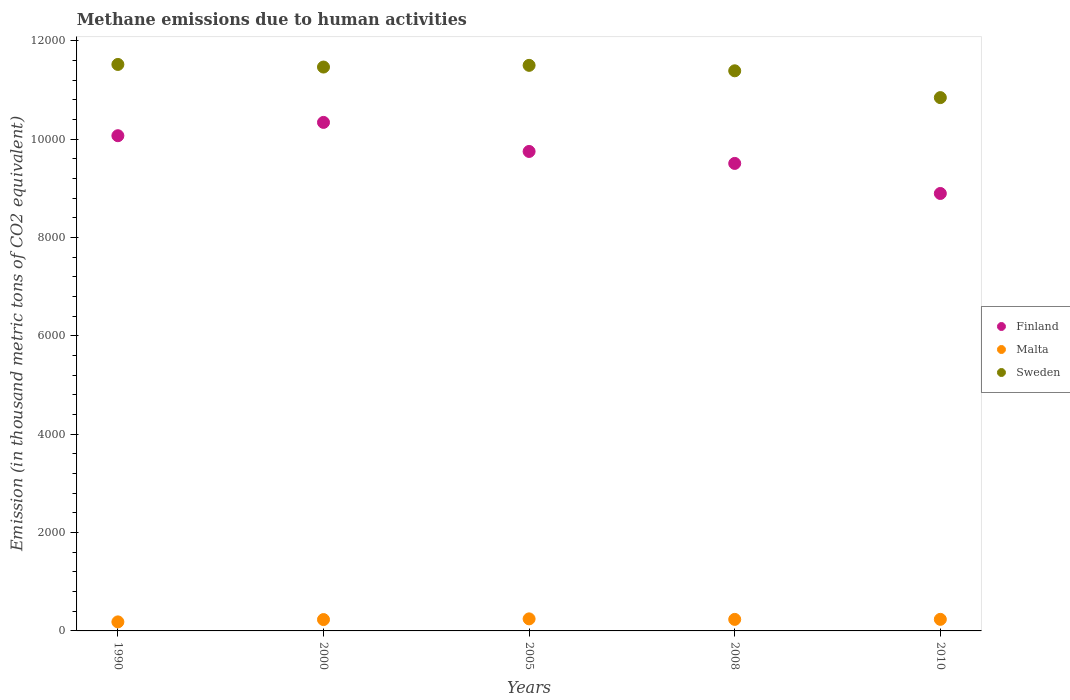How many different coloured dotlines are there?
Give a very brief answer. 3. What is the amount of methane emitted in Sweden in 2000?
Keep it short and to the point. 1.15e+04. Across all years, what is the maximum amount of methane emitted in Malta?
Your answer should be very brief. 245.1. Across all years, what is the minimum amount of methane emitted in Finland?
Your answer should be compact. 8895.5. In which year was the amount of methane emitted in Sweden minimum?
Offer a very short reply. 2010. What is the total amount of methane emitted in Finland in the graph?
Provide a short and direct response. 4.86e+04. What is the difference between the amount of methane emitted in Malta in 2008 and that in 2010?
Your response must be concise. -0.9. What is the difference between the amount of methane emitted in Sweden in 2000 and the amount of methane emitted in Finland in 2010?
Offer a terse response. 2570.8. What is the average amount of methane emitted in Finland per year?
Your answer should be very brief. 9712.64. In the year 2010, what is the difference between the amount of methane emitted in Sweden and amount of methane emitted in Malta?
Give a very brief answer. 1.06e+04. In how many years, is the amount of methane emitted in Malta greater than 9200 thousand metric tons?
Offer a very short reply. 0. What is the ratio of the amount of methane emitted in Sweden in 2008 to that in 2010?
Make the answer very short. 1.05. Is the difference between the amount of methane emitted in Sweden in 1990 and 2008 greater than the difference between the amount of methane emitted in Malta in 1990 and 2008?
Make the answer very short. Yes. What is the difference between the highest and the second highest amount of methane emitted in Finland?
Give a very brief answer. 270.6. What is the difference between the highest and the lowest amount of methane emitted in Sweden?
Give a very brief answer. 674.5. In how many years, is the amount of methane emitted in Finland greater than the average amount of methane emitted in Finland taken over all years?
Offer a terse response. 3. Is the sum of the amount of methane emitted in Malta in 1990 and 2000 greater than the maximum amount of methane emitted in Sweden across all years?
Offer a very short reply. No. Is it the case that in every year, the sum of the amount of methane emitted in Malta and amount of methane emitted in Sweden  is greater than the amount of methane emitted in Finland?
Your answer should be very brief. Yes. Does the amount of methane emitted in Malta monotonically increase over the years?
Provide a succinct answer. No. Is the amount of methane emitted in Finland strictly less than the amount of methane emitted in Malta over the years?
Your answer should be compact. No. How many dotlines are there?
Your answer should be very brief. 3. How many years are there in the graph?
Your answer should be very brief. 5. Are the values on the major ticks of Y-axis written in scientific E-notation?
Your answer should be compact. No. Where does the legend appear in the graph?
Your answer should be very brief. Center right. How many legend labels are there?
Give a very brief answer. 3. How are the legend labels stacked?
Keep it short and to the point. Vertical. What is the title of the graph?
Offer a terse response. Methane emissions due to human activities. Does "Liberia" appear as one of the legend labels in the graph?
Give a very brief answer. No. What is the label or title of the Y-axis?
Give a very brief answer. Emission (in thousand metric tons of CO2 equivalent). What is the Emission (in thousand metric tons of CO2 equivalent) in Finland in 1990?
Your answer should be compact. 1.01e+04. What is the Emission (in thousand metric tons of CO2 equivalent) in Malta in 1990?
Make the answer very short. 183.7. What is the Emission (in thousand metric tons of CO2 equivalent) of Sweden in 1990?
Offer a terse response. 1.15e+04. What is the Emission (in thousand metric tons of CO2 equivalent) in Finland in 2000?
Your answer should be compact. 1.03e+04. What is the Emission (in thousand metric tons of CO2 equivalent) in Malta in 2000?
Offer a very short reply. 230.8. What is the Emission (in thousand metric tons of CO2 equivalent) in Sweden in 2000?
Offer a very short reply. 1.15e+04. What is the Emission (in thousand metric tons of CO2 equivalent) in Finland in 2005?
Your answer should be very brief. 9750. What is the Emission (in thousand metric tons of CO2 equivalent) of Malta in 2005?
Keep it short and to the point. 245.1. What is the Emission (in thousand metric tons of CO2 equivalent) of Sweden in 2005?
Make the answer very short. 1.15e+04. What is the Emission (in thousand metric tons of CO2 equivalent) in Finland in 2008?
Ensure brevity in your answer.  9506.7. What is the Emission (in thousand metric tons of CO2 equivalent) of Malta in 2008?
Give a very brief answer. 234.5. What is the Emission (in thousand metric tons of CO2 equivalent) in Sweden in 2008?
Your answer should be very brief. 1.14e+04. What is the Emission (in thousand metric tons of CO2 equivalent) of Finland in 2010?
Ensure brevity in your answer.  8895.5. What is the Emission (in thousand metric tons of CO2 equivalent) in Malta in 2010?
Provide a succinct answer. 235.4. What is the Emission (in thousand metric tons of CO2 equivalent) of Sweden in 2010?
Your response must be concise. 1.08e+04. Across all years, what is the maximum Emission (in thousand metric tons of CO2 equivalent) of Finland?
Provide a succinct answer. 1.03e+04. Across all years, what is the maximum Emission (in thousand metric tons of CO2 equivalent) in Malta?
Your answer should be very brief. 245.1. Across all years, what is the maximum Emission (in thousand metric tons of CO2 equivalent) in Sweden?
Keep it short and to the point. 1.15e+04. Across all years, what is the minimum Emission (in thousand metric tons of CO2 equivalent) in Finland?
Provide a short and direct response. 8895.5. Across all years, what is the minimum Emission (in thousand metric tons of CO2 equivalent) in Malta?
Offer a terse response. 183.7. Across all years, what is the minimum Emission (in thousand metric tons of CO2 equivalent) in Sweden?
Your response must be concise. 1.08e+04. What is the total Emission (in thousand metric tons of CO2 equivalent) of Finland in the graph?
Provide a short and direct response. 4.86e+04. What is the total Emission (in thousand metric tons of CO2 equivalent) of Malta in the graph?
Your response must be concise. 1129.5. What is the total Emission (in thousand metric tons of CO2 equivalent) in Sweden in the graph?
Give a very brief answer. 5.67e+04. What is the difference between the Emission (in thousand metric tons of CO2 equivalent) in Finland in 1990 and that in 2000?
Your answer should be very brief. -270.6. What is the difference between the Emission (in thousand metric tons of CO2 equivalent) in Malta in 1990 and that in 2000?
Provide a succinct answer. -47.1. What is the difference between the Emission (in thousand metric tons of CO2 equivalent) in Finland in 1990 and that in 2005?
Provide a succinct answer. 320.2. What is the difference between the Emission (in thousand metric tons of CO2 equivalent) of Malta in 1990 and that in 2005?
Ensure brevity in your answer.  -61.4. What is the difference between the Emission (in thousand metric tons of CO2 equivalent) of Sweden in 1990 and that in 2005?
Offer a very short reply. 18.4. What is the difference between the Emission (in thousand metric tons of CO2 equivalent) of Finland in 1990 and that in 2008?
Ensure brevity in your answer.  563.5. What is the difference between the Emission (in thousand metric tons of CO2 equivalent) of Malta in 1990 and that in 2008?
Ensure brevity in your answer.  -50.8. What is the difference between the Emission (in thousand metric tons of CO2 equivalent) of Sweden in 1990 and that in 2008?
Give a very brief answer. 129.2. What is the difference between the Emission (in thousand metric tons of CO2 equivalent) in Finland in 1990 and that in 2010?
Offer a very short reply. 1174.7. What is the difference between the Emission (in thousand metric tons of CO2 equivalent) in Malta in 1990 and that in 2010?
Provide a succinct answer. -51.7. What is the difference between the Emission (in thousand metric tons of CO2 equivalent) in Sweden in 1990 and that in 2010?
Your response must be concise. 674.5. What is the difference between the Emission (in thousand metric tons of CO2 equivalent) in Finland in 2000 and that in 2005?
Keep it short and to the point. 590.8. What is the difference between the Emission (in thousand metric tons of CO2 equivalent) of Malta in 2000 and that in 2005?
Give a very brief answer. -14.3. What is the difference between the Emission (in thousand metric tons of CO2 equivalent) of Sweden in 2000 and that in 2005?
Ensure brevity in your answer.  -34.6. What is the difference between the Emission (in thousand metric tons of CO2 equivalent) in Finland in 2000 and that in 2008?
Your response must be concise. 834.1. What is the difference between the Emission (in thousand metric tons of CO2 equivalent) of Sweden in 2000 and that in 2008?
Offer a terse response. 76.2. What is the difference between the Emission (in thousand metric tons of CO2 equivalent) in Finland in 2000 and that in 2010?
Offer a terse response. 1445.3. What is the difference between the Emission (in thousand metric tons of CO2 equivalent) in Malta in 2000 and that in 2010?
Your answer should be very brief. -4.6. What is the difference between the Emission (in thousand metric tons of CO2 equivalent) of Sweden in 2000 and that in 2010?
Provide a short and direct response. 621.5. What is the difference between the Emission (in thousand metric tons of CO2 equivalent) in Finland in 2005 and that in 2008?
Your answer should be compact. 243.3. What is the difference between the Emission (in thousand metric tons of CO2 equivalent) of Sweden in 2005 and that in 2008?
Ensure brevity in your answer.  110.8. What is the difference between the Emission (in thousand metric tons of CO2 equivalent) in Finland in 2005 and that in 2010?
Your response must be concise. 854.5. What is the difference between the Emission (in thousand metric tons of CO2 equivalent) in Malta in 2005 and that in 2010?
Your answer should be compact. 9.7. What is the difference between the Emission (in thousand metric tons of CO2 equivalent) in Sweden in 2005 and that in 2010?
Offer a very short reply. 656.1. What is the difference between the Emission (in thousand metric tons of CO2 equivalent) of Finland in 2008 and that in 2010?
Ensure brevity in your answer.  611.2. What is the difference between the Emission (in thousand metric tons of CO2 equivalent) in Malta in 2008 and that in 2010?
Offer a terse response. -0.9. What is the difference between the Emission (in thousand metric tons of CO2 equivalent) in Sweden in 2008 and that in 2010?
Provide a short and direct response. 545.3. What is the difference between the Emission (in thousand metric tons of CO2 equivalent) in Finland in 1990 and the Emission (in thousand metric tons of CO2 equivalent) in Malta in 2000?
Provide a succinct answer. 9839.4. What is the difference between the Emission (in thousand metric tons of CO2 equivalent) of Finland in 1990 and the Emission (in thousand metric tons of CO2 equivalent) of Sweden in 2000?
Offer a very short reply. -1396.1. What is the difference between the Emission (in thousand metric tons of CO2 equivalent) of Malta in 1990 and the Emission (in thousand metric tons of CO2 equivalent) of Sweden in 2000?
Keep it short and to the point. -1.13e+04. What is the difference between the Emission (in thousand metric tons of CO2 equivalent) of Finland in 1990 and the Emission (in thousand metric tons of CO2 equivalent) of Malta in 2005?
Offer a terse response. 9825.1. What is the difference between the Emission (in thousand metric tons of CO2 equivalent) in Finland in 1990 and the Emission (in thousand metric tons of CO2 equivalent) in Sweden in 2005?
Your answer should be compact. -1430.7. What is the difference between the Emission (in thousand metric tons of CO2 equivalent) of Malta in 1990 and the Emission (in thousand metric tons of CO2 equivalent) of Sweden in 2005?
Provide a short and direct response. -1.13e+04. What is the difference between the Emission (in thousand metric tons of CO2 equivalent) in Finland in 1990 and the Emission (in thousand metric tons of CO2 equivalent) in Malta in 2008?
Your response must be concise. 9835.7. What is the difference between the Emission (in thousand metric tons of CO2 equivalent) of Finland in 1990 and the Emission (in thousand metric tons of CO2 equivalent) of Sweden in 2008?
Provide a succinct answer. -1319.9. What is the difference between the Emission (in thousand metric tons of CO2 equivalent) in Malta in 1990 and the Emission (in thousand metric tons of CO2 equivalent) in Sweden in 2008?
Your answer should be very brief. -1.12e+04. What is the difference between the Emission (in thousand metric tons of CO2 equivalent) in Finland in 1990 and the Emission (in thousand metric tons of CO2 equivalent) in Malta in 2010?
Ensure brevity in your answer.  9834.8. What is the difference between the Emission (in thousand metric tons of CO2 equivalent) in Finland in 1990 and the Emission (in thousand metric tons of CO2 equivalent) in Sweden in 2010?
Your response must be concise. -774.6. What is the difference between the Emission (in thousand metric tons of CO2 equivalent) of Malta in 1990 and the Emission (in thousand metric tons of CO2 equivalent) of Sweden in 2010?
Offer a terse response. -1.07e+04. What is the difference between the Emission (in thousand metric tons of CO2 equivalent) of Finland in 2000 and the Emission (in thousand metric tons of CO2 equivalent) of Malta in 2005?
Your answer should be very brief. 1.01e+04. What is the difference between the Emission (in thousand metric tons of CO2 equivalent) in Finland in 2000 and the Emission (in thousand metric tons of CO2 equivalent) in Sweden in 2005?
Offer a terse response. -1160.1. What is the difference between the Emission (in thousand metric tons of CO2 equivalent) in Malta in 2000 and the Emission (in thousand metric tons of CO2 equivalent) in Sweden in 2005?
Your answer should be compact. -1.13e+04. What is the difference between the Emission (in thousand metric tons of CO2 equivalent) of Finland in 2000 and the Emission (in thousand metric tons of CO2 equivalent) of Malta in 2008?
Provide a succinct answer. 1.01e+04. What is the difference between the Emission (in thousand metric tons of CO2 equivalent) in Finland in 2000 and the Emission (in thousand metric tons of CO2 equivalent) in Sweden in 2008?
Your response must be concise. -1049.3. What is the difference between the Emission (in thousand metric tons of CO2 equivalent) in Malta in 2000 and the Emission (in thousand metric tons of CO2 equivalent) in Sweden in 2008?
Your response must be concise. -1.12e+04. What is the difference between the Emission (in thousand metric tons of CO2 equivalent) in Finland in 2000 and the Emission (in thousand metric tons of CO2 equivalent) in Malta in 2010?
Provide a short and direct response. 1.01e+04. What is the difference between the Emission (in thousand metric tons of CO2 equivalent) of Finland in 2000 and the Emission (in thousand metric tons of CO2 equivalent) of Sweden in 2010?
Your response must be concise. -504. What is the difference between the Emission (in thousand metric tons of CO2 equivalent) of Malta in 2000 and the Emission (in thousand metric tons of CO2 equivalent) of Sweden in 2010?
Ensure brevity in your answer.  -1.06e+04. What is the difference between the Emission (in thousand metric tons of CO2 equivalent) in Finland in 2005 and the Emission (in thousand metric tons of CO2 equivalent) in Malta in 2008?
Make the answer very short. 9515.5. What is the difference between the Emission (in thousand metric tons of CO2 equivalent) in Finland in 2005 and the Emission (in thousand metric tons of CO2 equivalent) in Sweden in 2008?
Your answer should be very brief. -1640.1. What is the difference between the Emission (in thousand metric tons of CO2 equivalent) in Malta in 2005 and the Emission (in thousand metric tons of CO2 equivalent) in Sweden in 2008?
Offer a terse response. -1.11e+04. What is the difference between the Emission (in thousand metric tons of CO2 equivalent) of Finland in 2005 and the Emission (in thousand metric tons of CO2 equivalent) of Malta in 2010?
Ensure brevity in your answer.  9514.6. What is the difference between the Emission (in thousand metric tons of CO2 equivalent) of Finland in 2005 and the Emission (in thousand metric tons of CO2 equivalent) of Sweden in 2010?
Ensure brevity in your answer.  -1094.8. What is the difference between the Emission (in thousand metric tons of CO2 equivalent) of Malta in 2005 and the Emission (in thousand metric tons of CO2 equivalent) of Sweden in 2010?
Ensure brevity in your answer.  -1.06e+04. What is the difference between the Emission (in thousand metric tons of CO2 equivalent) of Finland in 2008 and the Emission (in thousand metric tons of CO2 equivalent) of Malta in 2010?
Make the answer very short. 9271.3. What is the difference between the Emission (in thousand metric tons of CO2 equivalent) of Finland in 2008 and the Emission (in thousand metric tons of CO2 equivalent) of Sweden in 2010?
Offer a terse response. -1338.1. What is the difference between the Emission (in thousand metric tons of CO2 equivalent) in Malta in 2008 and the Emission (in thousand metric tons of CO2 equivalent) in Sweden in 2010?
Offer a terse response. -1.06e+04. What is the average Emission (in thousand metric tons of CO2 equivalent) in Finland per year?
Make the answer very short. 9712.64. What is the average Emission (in thousand metric tons of CO2 equivalent) in Malta per year?
Offer a terse response. 225.9. What is the average Emission (in thousand metric tons of CO2 equivalent) in Sweden per year?
Offer a terse response. 1.13e+04. In the year 1990, what is the difference between the Emission (in thousand metric tons of CO2 equivalent) in Finland and Emission (in thousand metric tons of CO2 equivalent) in Malta?
Ensure brevity in your answer.  9886.5. In the year 1990, what is the difference between the Emission (in thousand metric tons of CO2 equivalent) in Finland and Emission (in thousand metric tons of CO2 equivalent) in Sweden?
Offer a terse response. -1449.1. In the year 1990, what is the difference between the Emission (in thousand metric tons of CO2 equivalent) in Malta and Emission (in thousand metric tons of CO2 equivalent) in Sweden?
Keep it short and to the point. -1.13e+04. In the year 2000, what is the difference between the Emission (in thousand metric tons of CO2 equivalent) of Finland and Emission (in thousand metric tons of CO2 equivalent) of Malta?
Provide a succinct answer. 1.01e+04. In the year 2000, what is the difference between the Emission (in thousand metric tons of CO2 equivalent) of Finland and Emission (in thousand metric tons of CO2 equivalent) of Sweden?
Offer a terse response. -1125.5. In the year 2000, what is the difference between the Emission (in thousand metric tons of CO2 equivalent) in Malta and Emission (in thousand metric tons of CO2 equivalent) in Sweden?
Keep it short and to the point. -1.12e+04. In the year 2005, what is the difference between the Emission (in thousand metric tons of CO2 equivalent) of Finland and Emission (in thousand metric tons of CO2 equivalent) of Malta?
Offer a very short reply. 9504.9. In the year 2005, what is the difference between the Emission (in thousand metric tons of CO2 equivalent) of Finland and Emission (in thousand metric tons of CO2 equivalent) of Sweden?
Offer a terse response. -1750.9. In the year 2005, what is the difference between the Emission (in thousand metric tons of CO2 equivalent) in Malta and Emission (in thousand metric tons of CO2 equivalent) in Sweden?
Your answer should be very brief. -1.13e+04. In the year 2008, what is the difference between the Emission (in thousand metric tons of CO2 equivalent) of Finland and Emission (in thousand metric tons of CO2 equivalent) of Malta?
Ensure brevity in your answer.  9272.2. In the year 2008, what is the difference between the Emission (in thousand metric tons of CO2 equivalent) of Finland and Emission (in thousand metric tons of CO2 equivalent) of Sweden?
Offer a terse response. -1883.4. In the year 2008, what is the difference between the Emission (in thousand metric tons of CO2 equivalent) in Malta and Emission (in thousand metric tons of CO2 equivalent) in Sweden?
Your answer should be very brief. -1.12e+04. In the year 2010, what is the difference between the Emission (in thousand metric tons of CO2 equivalent) in Finland and Emission (in thousand metric tons of CO2 equivalent) in Malta?
Give a very brief answer. 8660.1. In the year 2010, what is the difference between the Emission (in thousand metric tons of CO2 equivalent) in Finland and Emission (in thousand metric tons of CO2 equivalent) in Sweden?
Your response must be concise. -1949.3. In the year 2010, what is the difference between the Emission (in thousand metric tons of CO2 equivalent) in Malta and Emission (in thousand metric tons of CO2 equivalent) in Sweden?
Your answer should be very brief. -1.06e+04. What is the ratio of the Emission (in thousand metric tons of CO2 equivalent) in Finland in 1990 to that in 2000?
Provide a succinct answer. 0.97. What is the ratio of the Emission (in thousand metric tons of CO2 equivalent) in Malta in 1990 to that in 2000?
Offer a terse response. 0.8. What is the ratio of the Emission (in thousand metric tons of CO2 equivalent) in Sweden in 1990 to that in 2000?
Offer a terse response. 1. What is the ratio of the Emission (in thousand metric tons of CO2 equivalent) of Finland in 1990 to that in 2005?
Give a very brief answer. 1.03. What is the ratio of the Emission (in thousand metric tons of CO2 equivalent) in Malta in 1990 to that in 2005?
Your response must be concise. 0.75. What is the ratio of the Emission (in thousand metric tons of CO2 equivalent) of Sweden in 1990 to that in 2005?
Offer a very short reply. 1. What is the ratio of the Emission (in thousand metric tons of CO2 equivalent) in Finland in 1990 to that in 2008?
Provide a succinct answer. 1.06. What is the ratio of the Emission (in thousand metric tons of CO2 equivalent) of Malta in 1990 to that in 2008?
Keep it short and to the point. 0.78. What is the ratio of the Emission (in thousand metric tons of CO2 equivalent) in Sweden in 1990 to that in 2008?
Provide a succinct answer. 1.01. What is the ratio of the Emission (in thousand metric tons of CO2 equivalent) of Finland in 1990 to that in 2010?
Your answer should be very brief. 1.13. What is the ratio of the Emission (in thousand metric tons of CO2 equivalent) in Malta in 1990 to that in 2010?
Provide a short and direct response. 0.78. What is the ratio of the Emission (in thousand metric tons of CO2 equivalent) in Sweden in 1990 to that in 2010?
Keep it short and to the point. 1.06. What is the ratio of the Emission (in thousand metric tons of CO2 equivalent) of Finland in 2000 to that in 2005?
Offer a terse response. 1.06. What is the ratio of the Emission (in thousand metric tons of CO2 equivalent) in Malta in 2000 to that in 2005?
Offer a terse response. 0.94. What is the ratio of the Emission (in thousand metric tons of CO2 equivalent) of Finland in 2000 to that in 2008?
Offer a very short reply. 1.09. What is the ratio of the Emission (in thousand metric tons of CO2 equivalent) of Malta in 2000 to that in 2008?
Your answer should be compact. 0.98. What is the ratio of the Emission (in thousand metric tons of CO2 equivalent) of Finland in 2000 to that in 2010?
Provide a short and direct response. 1.16. What is the ratio of the Emission (in thousand metric tons of CO2 equivalent) of Malta in 2000 to that in 2010?
Your response must be concise. 0.98. What is the ratio of the Emission (in thousand metric tons of CO2 equivalent) of Sweden in 2000 to that in 2010?
Your answer should be very brief. 1.06. What is the ratio of the Emission (in thousand metric tons of CO2 equivalent) of Finland in 2005 to that in 2008?
Offer a terse response. 1.03. What is the ratio of the Emission (in thousand metric tons of CO2 equivalent) of Malta in 2005 to that in 2008?
Your answer should be very brief. 1.05. What is the ratio of the Emission (in thousand metric tons of CO2 equivalent) of Sweden in 2005 to that in 2008?
Give a very brief answer. 1.01. What is the ratio of the Emission (in thousand metric tons of CO2 equivalent) in Finland in 2005 to that in 2010?
Provide a succinct answer. 1.1. What is the ratio of the Emission (in thousand metric tons of CO2 equivalent) in Malta in 2005 to that in 2010?
Offer a terse response. 1.04. What is the ratio of the Emission (in thousand metric tons of CO2 equivalent) in Sweden in 2005 to that in 2010?
Your answer should be compact. 1.06. What is the ratio of the Emission (in thousand metric tons of CO2 equivalent) in Finland in 2008 to that in 2010?
Provide a short and direct response. 1.07. What is the ratio of the Emission (in thousand metric tons of CO2 equivalent) in Sweden in 2008 to that in 2010?
Your answer should be very brief. 1.05. What is the difference between the highest and the second highest Emission (in thousand metric tons of CO2 equivalent) of Finland?
Provide a succinct answer. 270.6. What is the difference between the highest and the second highest Emission (in thousand metric tons of CO2 equivalent) of Malta?
Your answer should be compact. 9.7. What is the difference between the highest and the second highest Emission (in thousand metric tons of CO2 equivalent) in Sweden?
Provide a short and direct response. 18.4. What is the difference between the highest and the lowest Emission (in thousand metric tons of CO2 equivalent) of Finland?
Offer a terse response. 1445.3. What is the difference between the highest and the lowest Emission (in thousand metric tons of CO2 equivalent) in Malta?
Give a very brief answer. 61.4. What is the difference between the highest and the lowest Emission (in thousand metric tons of CO2 equivalent) in Sweden?
Your answer should be very brief. 674.5. 